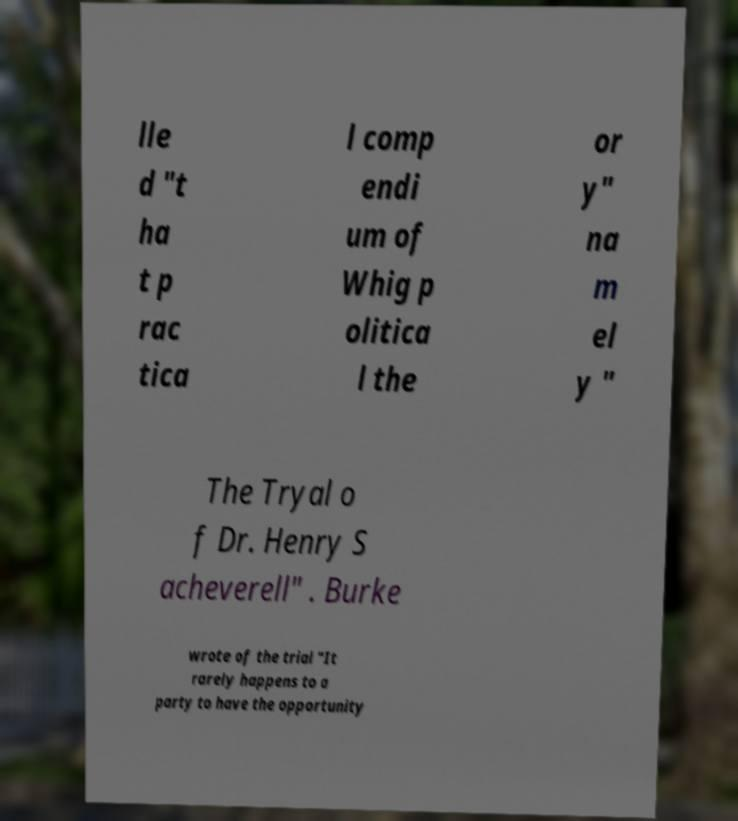I need the written content from this picture converted into text. Can you do that? lle d "t ha t p rac tica l comp endi um of Whig p olitica l the or y" na m el y " The Tryal o f Dr. Henry S acheverell" . Burke wrote of the trial "It rarely happens to a party to have the opportunity 